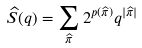<formula> <loc_0><loc_0><loc_500><loc_500>\widehat { S } ( q ) = \sum _ { \widehat { \pi } } 2 ^ { p ( \widehat { \pi } ) } q ^ { | \widehat { \pi } | }</formula> 